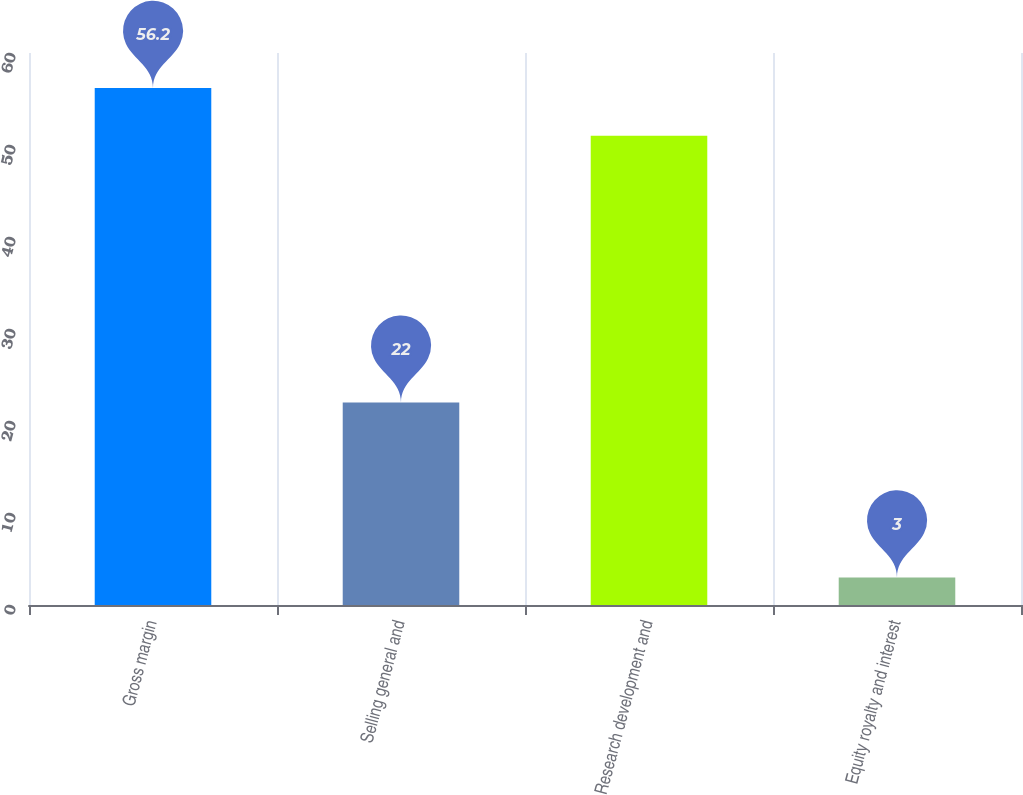<chart> <loc_0><loc_0><loc_500><loc_500><bar_chart><fcel>Gross margin<fcel>Selling general and<fcel>Research development and<fcel>Equity royalty and interest<nl><fcel>56.2<fcel>22<fcel>51<fcel>3<nl></chart> 